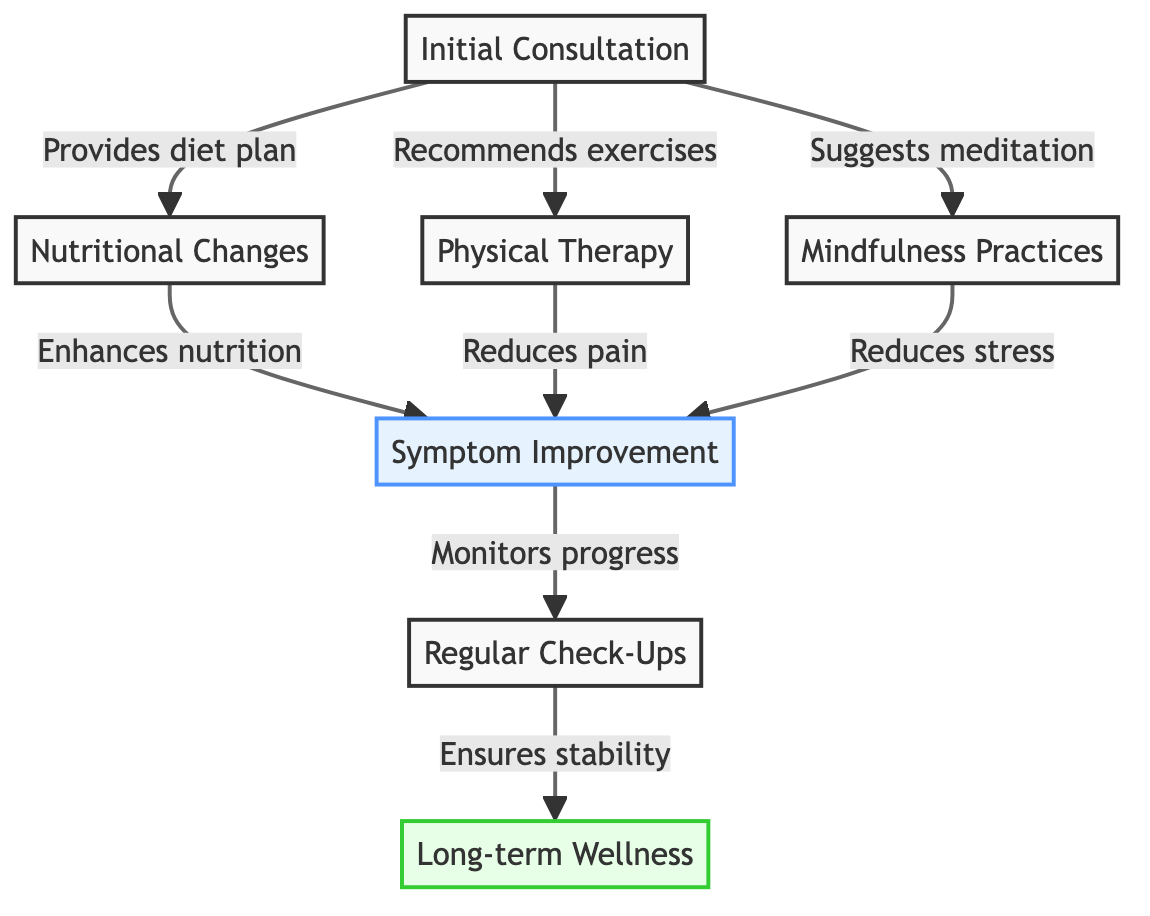What node follows the Initial Consultation? According to the diagram, the Initial Consultation node connects directly to three other nodes: Nutritional Changes, Physical Therapy, and Mindfulness Practices. These represent treatments that are recommended immediately after the consultation.
Answer: Nutritional Changes, Physical Therapy, Mindfulness Practices How many main treatment options are indicated in the diagram? The diagram shows three main treatment options that follow the Initial Consultation. These are Nutritional Changes, Physical Therapy, and Mindfulness Practices.
Answer: Three What is the purpose of regular check-ups? In the flow of the diagram, the arrow leading from Symptom Improvement to Regular Check-Ups indicates that regular check-ups serve to monitor progress, ensuring that the improvements in symptoms are maintained over time.
Answer: Ensures stability What is the final outcome represented in the diagram? The final node in the diagram is Long-term Wellness, which is reached after Regular Check-Ups that ensure stability in health improvements. This node symbolizes a lasting state of health achieved through the holistic treatments.
Answer: Long-term Wellness How do mindfulness practices contribute to the treatment process? The diagram shows that Mindfulness Practices lead to Symptom Improvement by reducing stress. This pathway demonstrates how incorporating mindfulness into the treatment plan directly contributes to better health outcomes.
Answer: Reduces stress What relationship exists between Physical Therapy and Symptom Improvement? The diagram indicates that Physical Therapy has a direct effect on Symptom Improvement, specifically by reducing pain. This is represented by the arrow connecting Physical Therapy directly to the Symptom Improvement node.
Answer: Reduces pain 